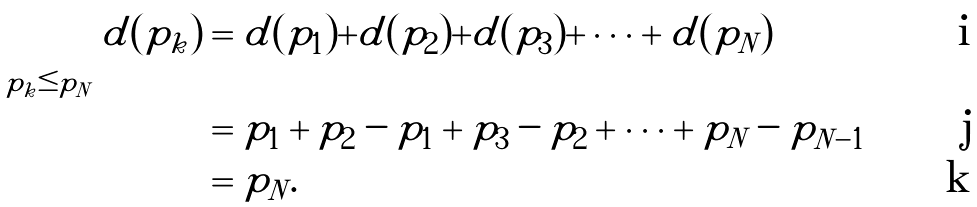Convert formula to latex. <formula><loc_0><loc_0><loc_500><loc_500>\sum _ { p _ { k } \leq p _ { N } } d ( p _ { k } ) & = d ( p _ { 1 } ) + d ( p _ { 2 } ) + d ( p _ { 3 } ) + \cdots + d ( p _ { N } ) \\ & = p _ { 1 } + p _ { 2 } - p _ { 1 } + p _ { 3 } - p _ { 2 } + \cdots + p _ { N } - p _ { N - 1 } \\ & = p _ { N } .</formula> 